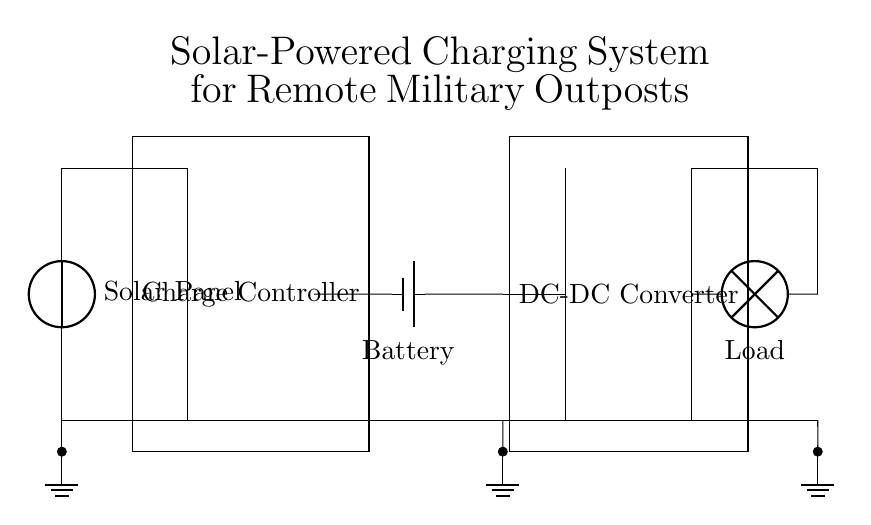What component converts solar energy into electrical energy? The solar panel is indicated as the component labeled "Solar Panel" in the circuit diagram, which suggests that it converts solar energy into electrical energy.
Answer: Solar Panel What is the purpose of the charge controller? The charge controller is designed to regulate the voltage and current coming from the solar panel to prevent overcharging of the battery, as shown by its placement between the solar panel and the battery in the circuit.
Answer: Regulate voltage and current What is the role of the DC-DC converter in this circuit? The DC-DC converter adjusts the voltage level supplied to the load, as it is connected after the battery and before the load in the circuit, ensuring appropriate voltage for the load's operation.
Answer: Adjust voltage level How many main components are in this circuit? The circuit consists of four main components: the solar panel, charge controller, battery, and DC-DC converter, which are clearly represented in the diagram.
Answer: Four What is the initial voltage source in the circuit? The initial voltage source is the solar panel, which provides the required energy to start the charging process as shown in the diagram.
Answer: Solar Panel What component is grounding the battery? The grounding of the battery is done through the ground symbol that connects to the battery's negative terminal, which is depicted as a ground mark in the diagram.
Answer: Ground symbol What is the load in this circuit diagram? The load is represented as a lamp in the circuit diagram, which indicates that it is the component using the energy supplied by the battery and DC-DC converter.
Answer: Lamp 